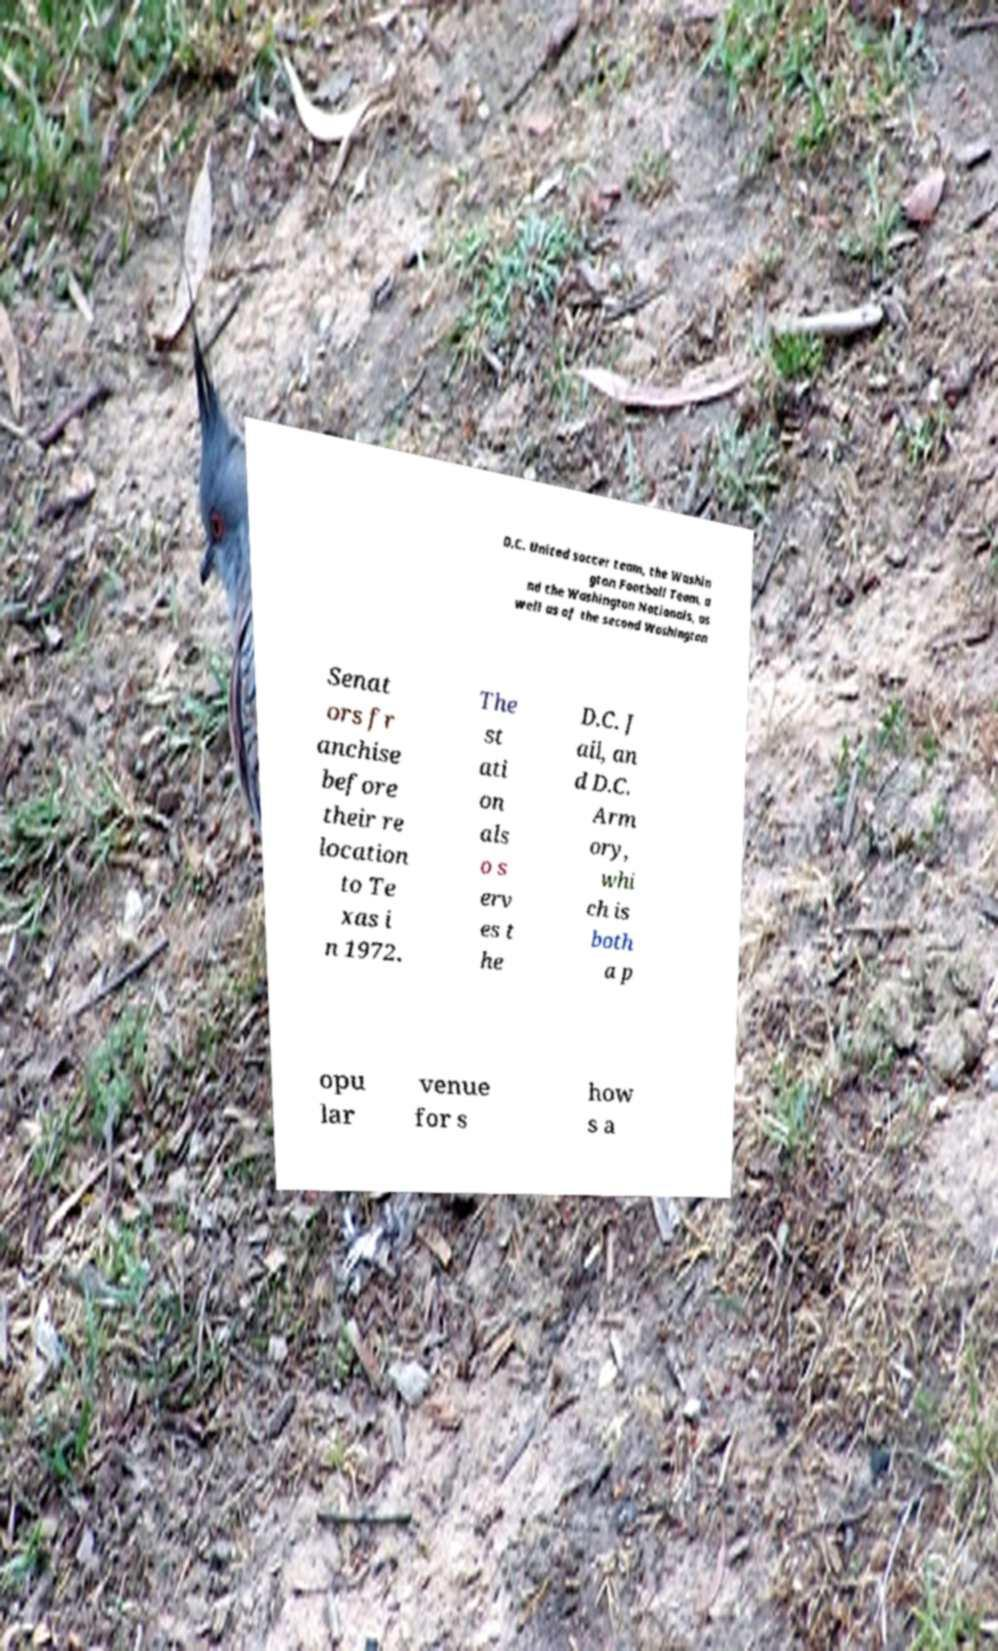Please read and relay the text visible in this image. What does it say? D.C. United soccer team, the Washin gton Football Team, a nd the Washington Nationals, as well as of the second Washington Senat ors fr anchise before their re location to Te xas i n 1972. The st ati on als o s erv es t he D.C. J ail, an d D.C. Arm ory, whi ch is both a p opu lar venue for s how s a 